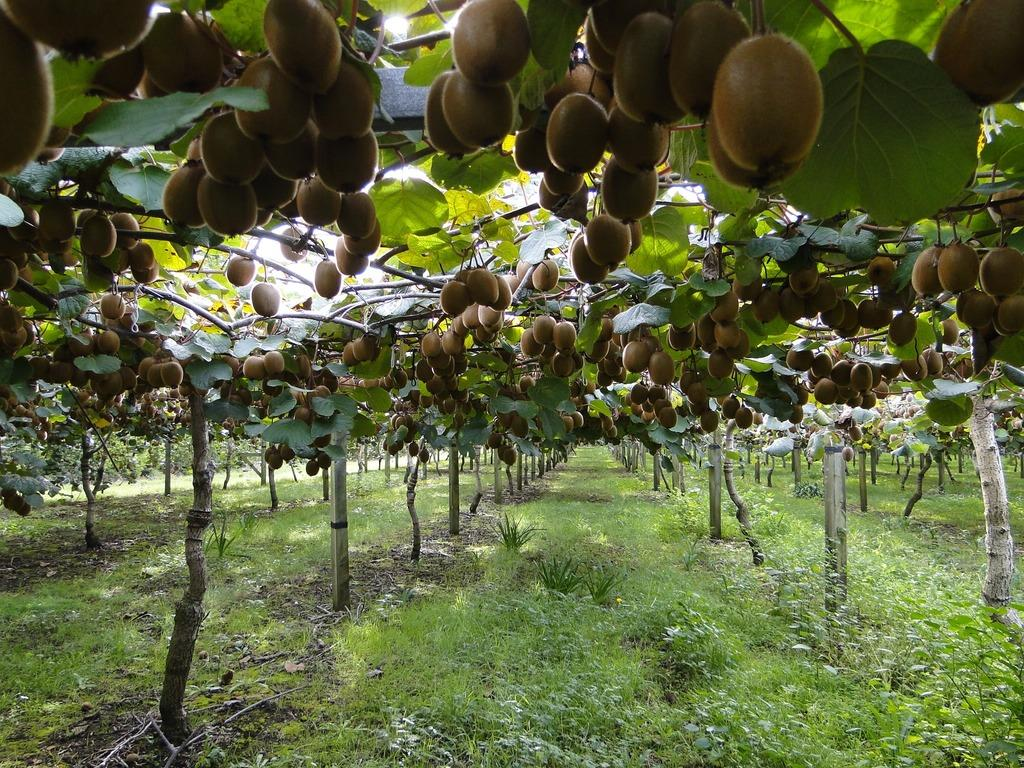What type of vegetation is present in the image? There is grass, green plants on the ground, and trees in the image. What is growing on the trees in the image? There are fruits on the trees in the image. What is the color of the fruits on the trees? The fruits are brown in color. Can you tell me how many baseballs are lying on the grass in the image? There are no baseballs present in the image; it features grass, green plants, trees, and fruits. 